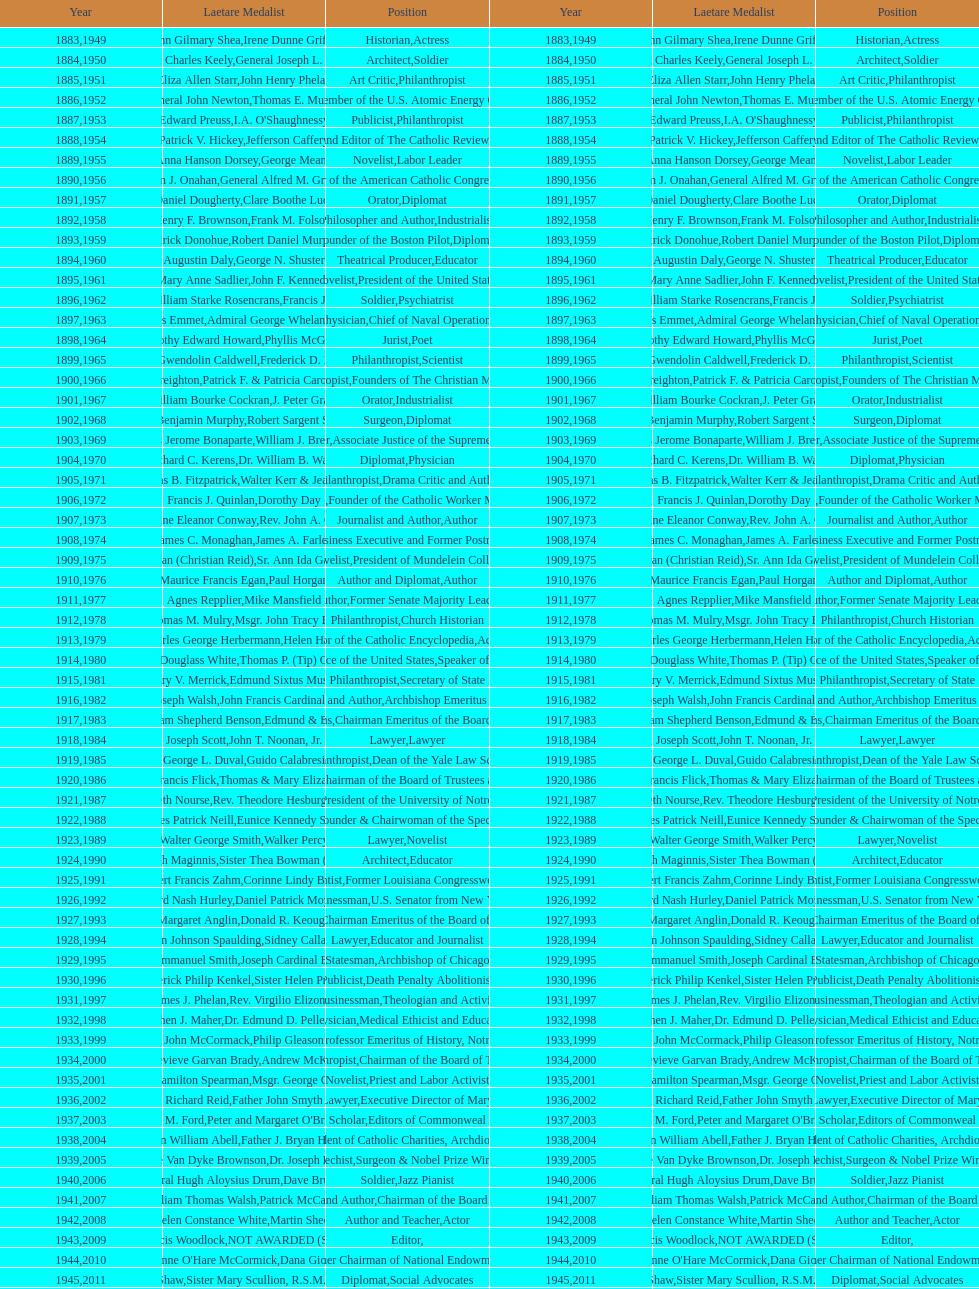Could you help me parse every detail presented in this table? {'header': ['Year', 'Laetare Medalist', 'Position', 'Year', 'Laetare Medalist', 'Position'], 'rows': [['1883', 'John Gilmary Shea', 'Historian', '1949', 'Irene Dunne Griffin', 'Actress'], ['1884', 'Patrick Charles Keely', 'Architect', '1950', 'General Joseph L. Collins', 'Soldier'], ['1885', 'Eliza Allen Starr', 'Art Critic', '1951', 'John Henry Phelan', 'Philanthropist'], ['1886', 'General John Newton', 'Engineer', '1952', 'Thomas E. Murray', 'Member of the U.S. Atomic Energy Commission'], ['1887', 'Edward Preuss', 'Publicist', '1953', "I.A. O'Shaughnessy", 'Philanthropist'], ['1888', 'Patrick V. Hickey', 'Founder and Editor of The Catholic Review', '1954', 'Jefferson Caffery', 'Diplomat'], ['1889', 'Anna Hanson Dorsey', 'Novelist', '1955', 'George Meany', 'Labor Leader'], ['1890', 'William J. Onahan', 'Organizer of the American Catholic Congress', '1956', 'General Alfred M. Gruenther', 'Soldier'], ['1891', 'Daniel Dougherty', 'Orator', '1957', 'Clare Boothe Luce', 'Diplomat'], ['1892', 'Henry F. Brownson', 'Philosopher and Author', '1958', 'Frank M. Folsom', 'Industrialist'], ['1893', 'Patrick Donohue', 'Founder of the Boston Pilot', '1959', 'Robert Daniel Murphy', 'Diplomat'], ['1894', 'Augustin Daly', 'Theatrical Producer', '1960', 'George N. Shuster', 'Educator'], ['1895', 'Mary Anne Sadlier', 'Novelist', '1961', 'John F. Kennedy', 'President of the United States'], ['1896', 'General William Starke Rosencrans', 'Soldier', '1962', 'Francis J. Braceland', 'Psychiatrist'], ['1897', 'Thomas Addis Emmet', 'Physician', '1963', 'Admiral George Whelan Anderson, Jr.', 'Chief of Naval Operations'], ['1898', 'Timothy Edward Howard', 'Jurist', '1964', 'Phyllis McGinley', 'Poet'], ['1899', 'Mary Gwendolin Caldwell', 'Philanthropist', '1965', 'Frederick D. Rossini', 'Scientist'], ['1900', 'John A. Creighton', 'Philanthropist', '1966', 'Patrick F. & Patricia Caron Crowley', 'Founders of The Christian Movement'], ['1901', 'William Bourke Cockran', 'Orator', '1967', 'J. Peter Grace', 'Industrialist'], ['1902', 'John Benjamin Murphy', 'Surgeon', '1968', 'Robert Sargent Shriver', 'Diplomat'], ['1903', 'Charles Jerome Bonaparte', 'Lawyer', '1969', 'William J. Brennan Jr.', 'Associate Justice of the Supreme Court'], ['1904', 'Richard C. Kerens', 'Diplomat', '1970', 'Dr. William B. Walsh', 'Physician'], ['1905', 'Thomas B. Fitzpatrick', 'Philanthropist', '1971', 'Walter Kerr & Jean Kerr', 'Drama Critic and Author'], ['1906', 'Francis J. Quinlan', 'Physician', '1972', 'Dorothy Day', 'Founder of the Catholic Worker Movement'], ['1907', 'Katherine Eleanor Conway', 'Journalist and Author', '1973', "Rev. John A. O'Brien", 'Author'], ['1908', 'James C. Monaghan', 'Economist', '1974', 'James A. Farley', 'Business Executive and Former Postmaster General'], ['1909', 'Frances Tieran (Christian Reid)', 'Novelist', '1975', 'Sr. Ann Ida Gannon, BMV', 'President of Mundelein College'], ['1910', 'Maurice Francis Egan', 'Author and Diplomat', '1976', 'Paul Horgan', 'Author'], ['1911', 'Agnes Repplier', 'Author', '1977', 'Mike Mansfield', 'Former Senate Majority Leader'], ['1912', 'Thomas M. Mulry', 'Philanthropist', '1978', 'Msgr. John Tracy Ellis', 'Church Historian'], ['1913', 'Charles George Herbermann', 'Editor of the Catholic Encyclopedia', '1979', 'Helen Hayes', 'Actress'], ['1914', 'Edward Douglass White', 'Chief Justice of the United States', '1980', "Thomas P. (Tip) O'Neill Jr.", 'Speaker of the House'], ['1915', 'Mary V. Merrick', 'Philanthropist', '1981', 'Edmund Sixtus Muskie', 'Secretary of State'], ['1916', 'James Joseph Walsh', 'Physician and Author', '1982', 'John Francis Cardinal Dearden', 'Archbishop Emeritus of Detroit'], ['1917', 'Admiral William Shepherd Benson', 'Chief of Naval Operations', '1983', 'Edmund & Evelyn Stephan', 'Chairman Emeritus of the Board of Trustees and his wife'], ['1918', 'Joseph Scott', 'Lawyer', '1984', 'John T. Noonan, Jr.', 'Lawyer'], ['1919', 'George L. Duval', 'Philanthropist', '1985', 'Guido Calabresi', 'Dean of the Yale Law School'], ['1920', 'Lawrence Francis Flick', 'Physician', '1986', 'Thomas & Mary Elizabeth Carney', 'Chairman of the Board of Trustees and his wife'], ['1921', 'Elizabeth Nourse', 'Artist', '1987', 'Rev. Theodore Hesburgh, CSC', 'President of the University of Notre Dame'], ['1922', 'Charles Patrick Neill', 'Economist', '1988', 'Eunice Kennedy Shriver', 'Founder & Chairwoman of the Special Olympics'], ['1923', 'Walter George Smith', 'Lawyer', '1989', 'Walker Percy', 'Novelist'], ['1924', 'Charles Donagh Maginnis', 'Architect', '1990', 'Sister Thea Bowman (posthumously)', 'Educator'], ['1925', 'Albert Francis Zahm', 'Scientist', '1991', 'Corinne Lindy Boggs', 'Former Louisiana Congresswoman'], ['1926', 'Edward Nash Hurley', 'Businessman', '1992', 'Daniel Patrick Moynihan', 'U.S. Senator from New York'], ['1927', 'Margaret Anglin', 'Actress', '1993', 'Donald R. Keough', 'Chairman Emeritus of the Board of Trustees'], ['1928', 'John Johnson Spaulding', 'Lawyer', '1994', 'Sidney Callahan', 'Educator and Journalist'], ['1929', 'Alfred Emmanuel Smith', 'Statesman', '1995', 'Joseph Cardinal Bernardin', 'Archbishop of Chicago'], ['1930', 'Frederick Philip Kenkel', 'Publicist', '1996', 'Sister Helen Prejean', 'Death Penalty Abolitionist'], ['1931', 'James J. Phelan', 'Businessman', '1997', 'Rev. Virgilio Elizondo', 'Theologian and Activist'], ['1932', 'Stephen J. Maher', 'Physician', '1998', 'Dr. Edmund D. Pellegrino', 'Medical Ethicist and Educator'], ['1933', 'John McCormack', 'Artist', '1999', 'Philip Gleason', 'Professor Emeritus of History, Notre Dame'], ['1934', 'Genevieve Garvan Brady', 'Philanthropist', '2000', 'Andrew McKenna', 'Chairman of the Board of Trustees'], ['1935', 'Francis Hamilton Spearman', 'Novelist', '2001', 'Msgr. George G. Higgins', 'Priest and Labor Activist'], ['1936', 'Richard Reid', 'Journalist and Lawyer', '2002', 'Father John Smyth', 'Executive Director of Maryville Academy'], ['1937', 'Jeremiah D. M. Ford', 'Scholar', '2003', "Peter and Margaret O'Brien Steinfels", 'Editors of Commonweal'], ['1938', 'Irvin William Abell', 'Surgeon', '2004', 'Father J. Bryan Hehir', 'President of Catholic Charities, Archdiocese of Boston'], ['1939', 'Josephine Van Dyke Brownson', 'Catechist', '2005', 'Dr. Joseph E. Murray', 'Surgeon & Nobel Prize Winner'], ['1940', 'General Hugh Aloysius Drum', 'Soldier', '2006', 'Dave Brubeck', 'Jazz Pianist'], ['1941', 'William Thomas Walsh', 'Journalist and Author', '2007', 'Patrick McCartan', 'Chairman of the Board of Trustees'], ['1942', 'Helen Constance White', 'Author and Teacher', '2008', 'Martin Sheen', 'Actor'], ['1943', 'Thomas Francis Woodlock', 'Editor', '2009', 'NOT AWARDED (SEE BELOW)', ''], ['1944', "Anne O'Hare McCormick", 'Journalist', '2010', 'Dana Gioia', 'Former Chairman of National Endowment for the Arts'], ['1945', 'Gardiner Howland Shaw', 'Diplomat', '2011', 'Sister Mary Scullion, R.S.M., & Joan McConnon', 'Social Advocates'], ['1946', 'Carlton J. H. Hayes', 'Historian and Diplomat', '2012', 'Ken Hackett', 'Former President of Catholic Relief Services'], ['1947', 'William G. Bruce', 'Publisher and Civic Leader', '2013', 'Sister Susanne Gallagher, S.P.\\nSister Mary Therese Harrington, S.H.\\nRev. James H. McCarthy', 'Founders of S.P.R.E.D. (Special Religious Education Development Network)'], ['1948', 'Frank C. Walker', 'Postmaster General and Civic Leader', '2014', 'Kenneth R. Miller', 'Professor of Biology at Brown University']]} Who was the recipient of the medal after thomas e. murray in 1952? I.A. O'Shaughnessy. 